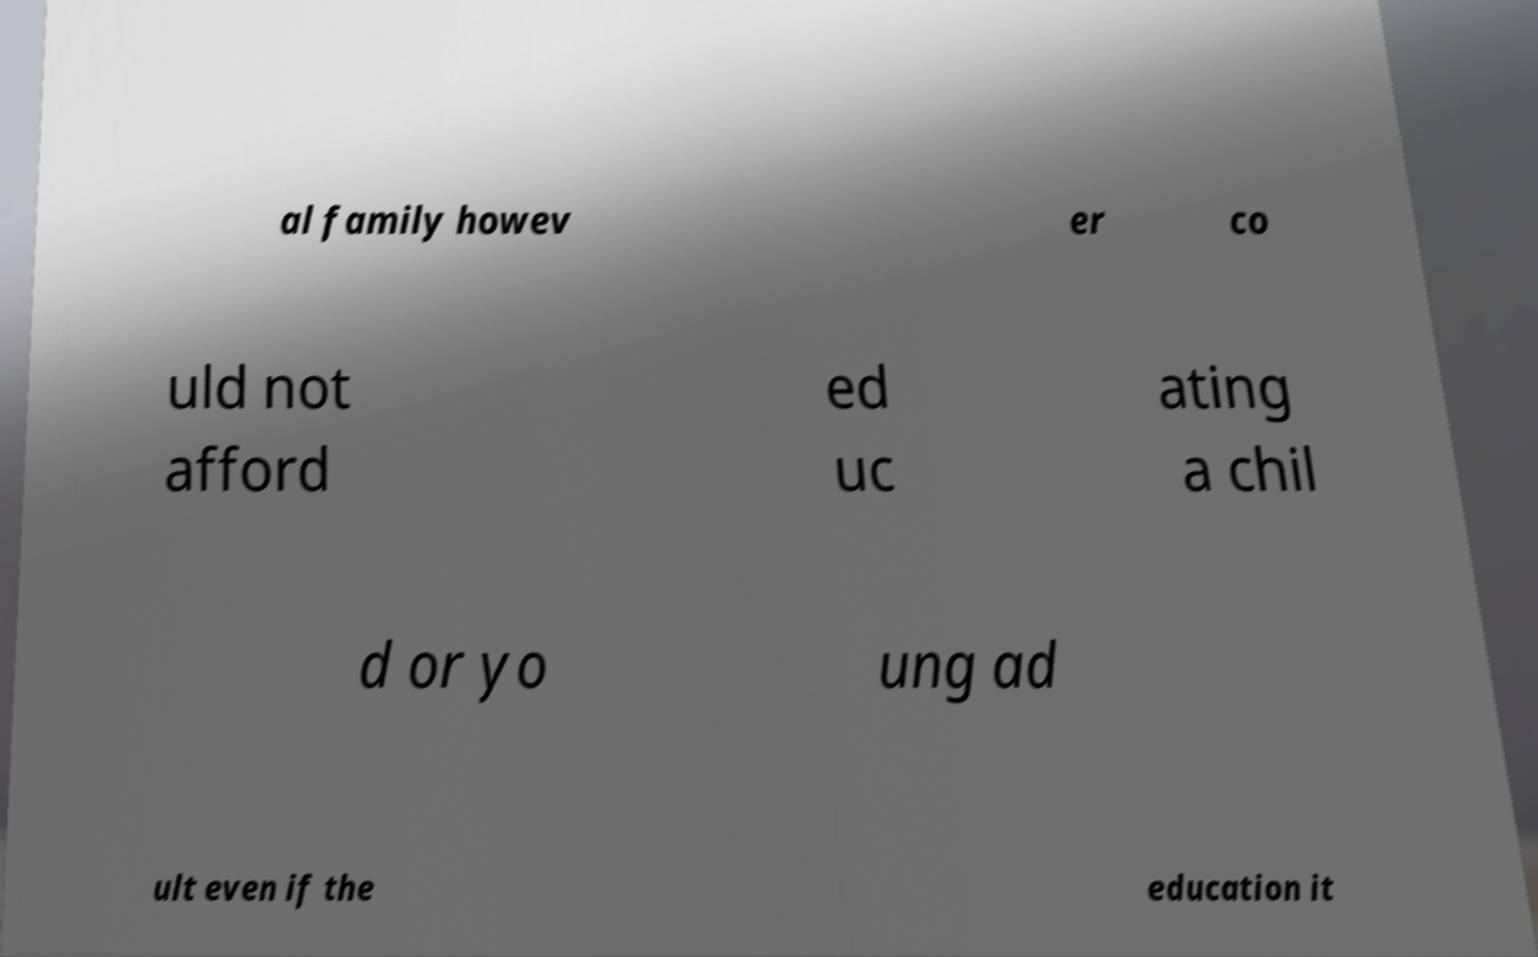Please read and relay the text visible in this image. What does it say? al family howev er co uld not afford ed uc ating a chil d or yo ung ad ult even if the education it 